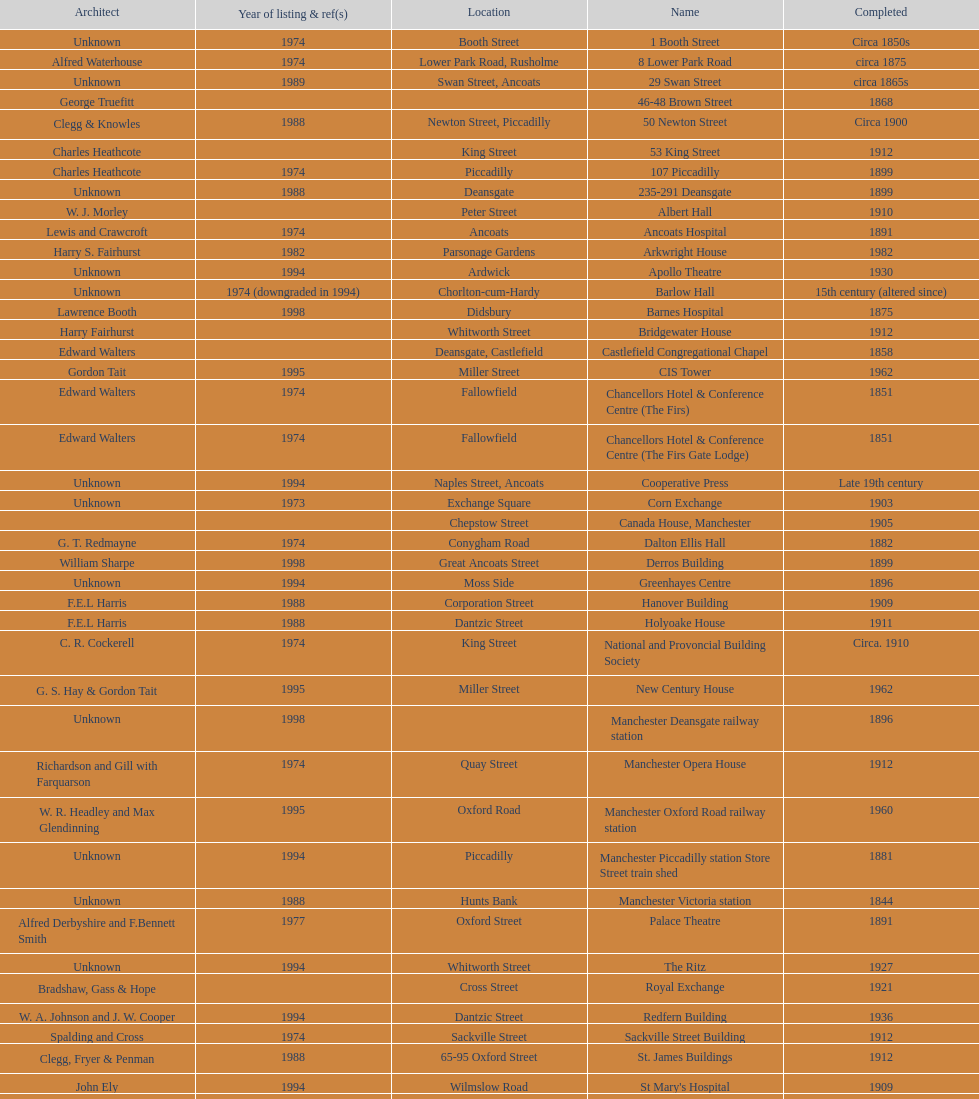Help me parse the entirety of this table. {'header': ['Architect', 'Year of listing & ref(s)', 'Location', 'Name', 'Completed'], 'rows': [['Unknown', '1974', 'Booth Street', '1 Booth Street', 'Circa 1850s'], ['Alfred Waterhouse', '1974', 'Lower Park Road, Rusholme', '8 Lower Park Road', 'circa 1875'], ['Unknown', '1989', 'Swan Street, Ancoats', '29 Swan Street', 'circa 1865s'], ['George Truefitt', '', '', '46-48 Brown Street', '1868'], ['Clegg & Knowles', '1988', 'Newton Street, Piccadilly', '50 Newton Street', 'Circa 1900'], ['Charles Heathcote', '', 'King Street', '53 King Street', '1912'], ['Charles Heathcote', '1974', 'Piccadilly', '107 Piccadilly', '1899'], ['Unknown', '1988', 'Deansgate', '235-291 Deansgate', '1899'], ['W. J. Morley', '', 'Peter Street', 'Albert Hall', '1910'], ['Lewis and Crawcroft', '1974', 'Ancoats', 'Ancoats Hospital', '1891'], ['Harry S. Fairhurst', '1982', 'Parsonage Gardens', 'Arkwright House', '1982'], ['Unknown', '1994', 'Ardwick', 'Apollo Theatre', '1930'], ['Unknown', '1974 (downgraded in 1994)', 'Chorlton-cum-Hardy', 'Barlow Hall', '15th century (altered since)'], ['Lawrence Booth', '1998', 'Didsbury', 'Barnes Hospital', '1875'], ['Harry Fairhurst', '', 'Whitworth Street', 'Bridgewater House', '1912'], ['Edward Walters', '', 'Deansgate, Castlefield', 'Castlefield Congregational Chapel', '1858'], ['Gordon Tait', '1995', 'Miller Street', 'CIS Tower', '1962'], ['Edward Walters', '1974', 'Fallowfield', 'Chancellors Hotel & Conference Centre (The Firs)', '1851'], ['Edward Walters', '1974', 'Fallowfield', 'Chancellors Hotel & Conference Centre (The Firs Gate Lodge)', '1851'], ['Unknown', '1994', 'Naples Street, Ancoats', 'Cooperative Press', 'Late 19th century'], ['Unknown', '1973', 'Exchange Square', 'Corn Exchange', '1903'], ['', '', 'Chepstow Street', 'Canada House, Manchester', '1905'], ['G. T. Redmayne', '1974', 'Conygham Road', 'Dalton Ellis Hall', '1882'], ['William Sharpe', '1998', 'Great Ancoats Street', 'Derros Building', '1899'], ['Unknown', '1994', 'Moss Side', 'Greenhayes Centre', '1896'], ['F.E.L Harris', '1988', 'Corporation Street', 'Hanover Building', '1909'], ['F.E.L Harris', '1988', 'Dantzic Street', 'Holyoake House', '1911'], ['C. R. Cockerell', '1974', 'King Street', 'National and Provoncial Building Society', 'Circa. 1910'], ['G. S. Hay & Gordon Tait', '1995', 'Miller Street', 'New Century House', '1962'], ['Unknown', '1998', '', 'Manchester Deansgate railway station', '1896'], ['Richardson and Gill with Farquarson', '1974', 'Quay Street', 'Manchester Opera House', '1912'], ['W. R. Headley and Max Glendinning', '1995', 'Oxford Road', 'Manchester Oxford Road railway station', '1960'], ['Unknown', '1994', 'Piccadilly', 'Manchester Piccadilly station Store Street train shed', '1881'], ['Unknown', '1988', 'Hunts Bank', 'Manchester Victoria station', '1844'], ['Alfred Derbyshire and F.Bennett Smith', '1977', 'Oxford Street', 'Palace Theatre', '1891'], ['Unknown', '1994', 'Whitworth Street', 'The Ritz', '1927'], ['Bradshaw, Gass & Hope', '', 'Cross Street', 'Royal Exchange', '1921'], ['W. A. Johnson and J. W. Cooper', '1994', 'Dantzic Street', 'Redfern Building', '1936'], ['Spalding and Cross', '1974', 'Sackville Street', 'Sackville Street Building', '1912'], ['Clegg, Fryer & Penman', '1988', '65-95 Oxford Street', 'St. James Buildings', '1912'], ['John Ely', '1994', 'Wilmslow Road', "St Mary's Hospital", '1909'], ['Percy Scott Worthington', '2010', 'Oxford Road', 'Samuel Alexander Building', '1919'], ['Harry S. Fairhurst', '1982', 'King Street', 'Ship Canal House', '1927'], ['Unknown', '1973', 'Swan Street, Ancoats', 'Smithfield Market Hall', '1857'], ['Alfred Waterhouse', '1974', 'Sherborne Street', 'Strangeways Gaol Gatehouse', '1868'], ['Alfred Waterhouse', '1974', 'Sherborne Street', 'Strangeways Prison ventilation and watch tower', '1868'], ['Irwin and Chester', '1974', 'Peter Street', 'Theatre Royal', '1845'], ['L. C. Howitt', '1999', 'Fallowfield', 'Toast Rack', '1960'], ['Unknown', '1952', 'Shambles Square', 'The Old Wellington Inn', 'Mid-16th century'], ['Unknown', '1974', 'Whitworth Park', 'Whitworth Park Mansions', 'Circa 1840s']]} What is the street of the only building listed in 1989? Swan Street. 